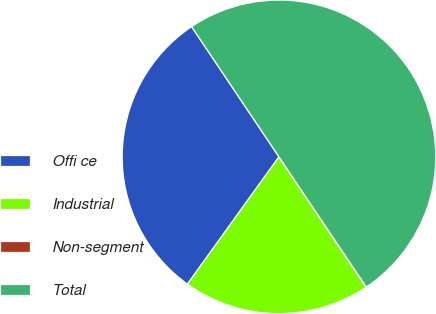Convert chart to OTSL. <chart><loc_0><loc_0><loc_500><loc_500><pie_chart><fcel>Offi ce<fcel>Industrial<fcel>Non-segment<fcel>Total<nl><fcel>30.67%<fcel>19.3%<fcel>0.03%<fcel>50.0%<nl></chart> 